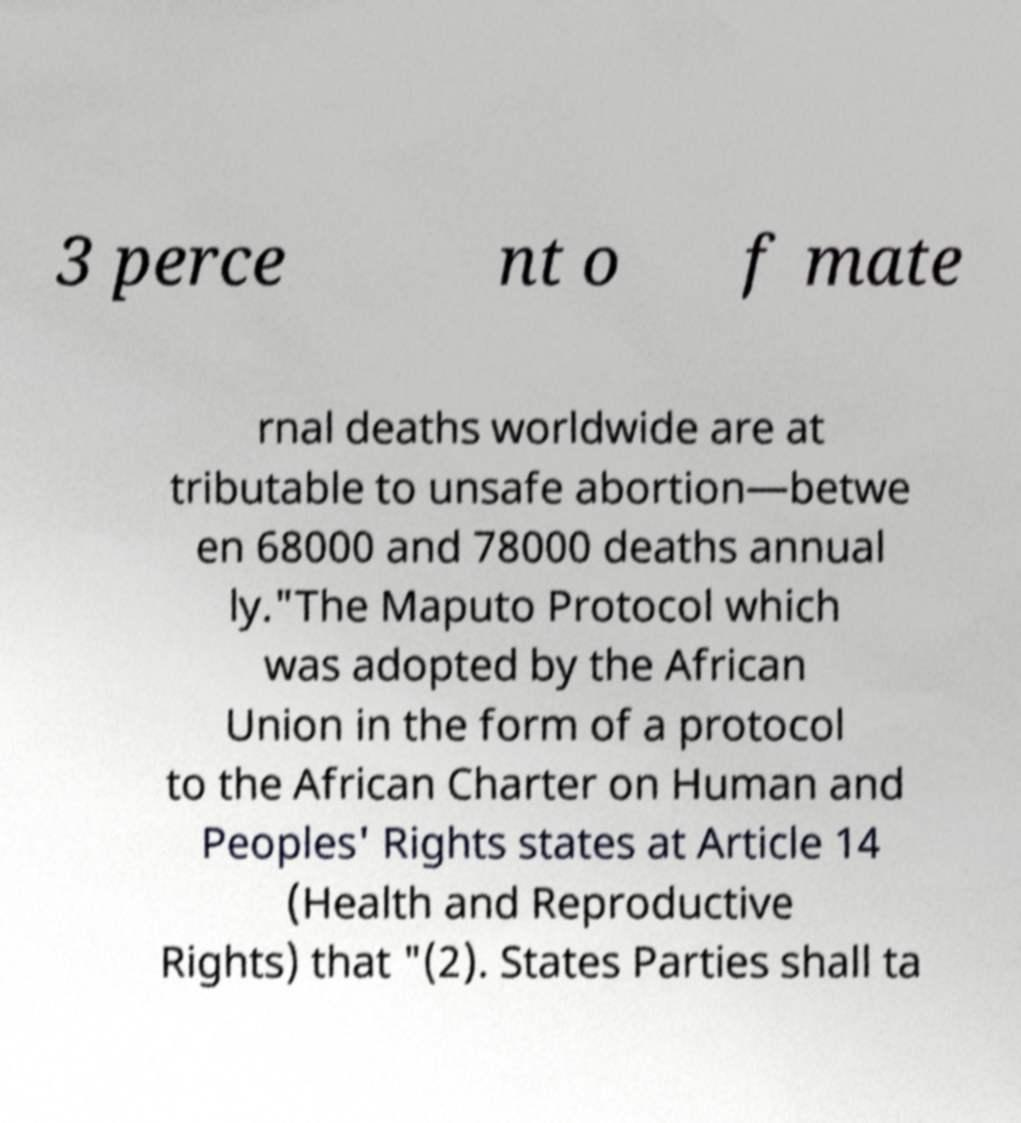Can you read and provide the text displayed in the image?This photo seems to have some interesting text. Can you extract and type it out for me? 3 perce nt o f mate rnal deaths worldwide are at tributable to unsafe abortion—betwe en 68000 and 78000 deaths annual ly."The Maputo Protocol which was adopted by the African Union in the form of a protocol to the African Charter on Human and Peoples' Rights states at Article 14 (Health and Reproductive Rights) that "(2). States Parties shall ta 